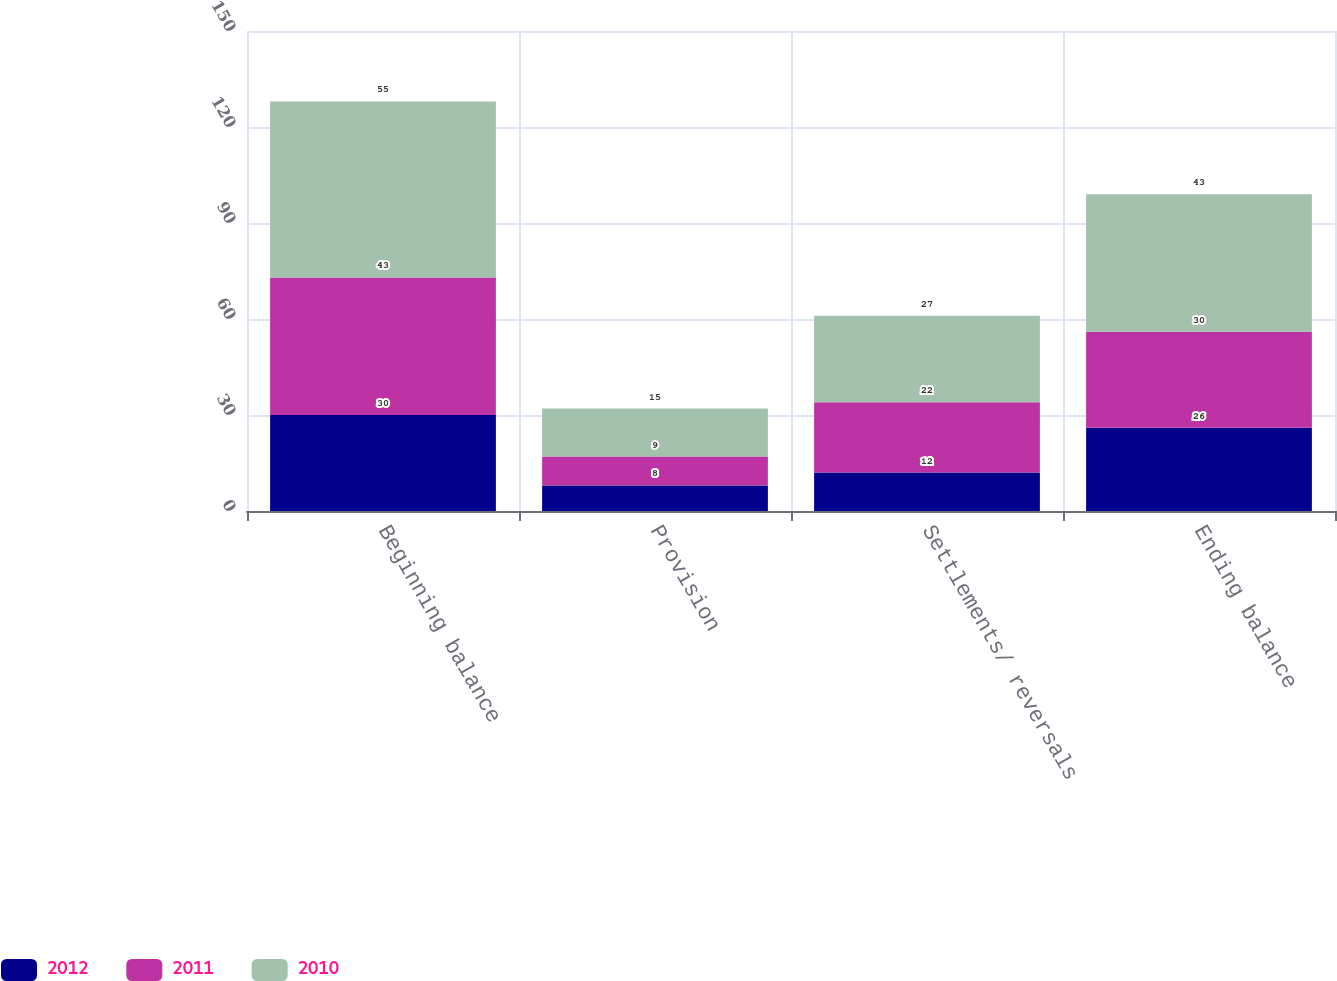Convert chart. <chart><loc_0><loc_0><loc_500><loc_500><stacked_bar_chart><ecel><fcel>Beginning balance<fcel>Provision<fcel>Settlements/ reversals<fcel>Ending balance<nl><fcel>2012<fcel>30<fcel>8<fcel>12<fcel>26<nl><fcel>2011<fcel>43<fcel>9<fcel>22<fcel>30<nl><fcel>2010<fcel>55<fcel>15<fcel>27<fcel>43<nl></chart> 